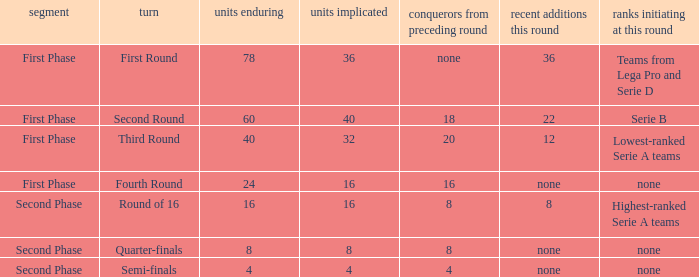When looking at new entries this round and seeing 8; what number in total is there for clubs remaining? 1.0. 